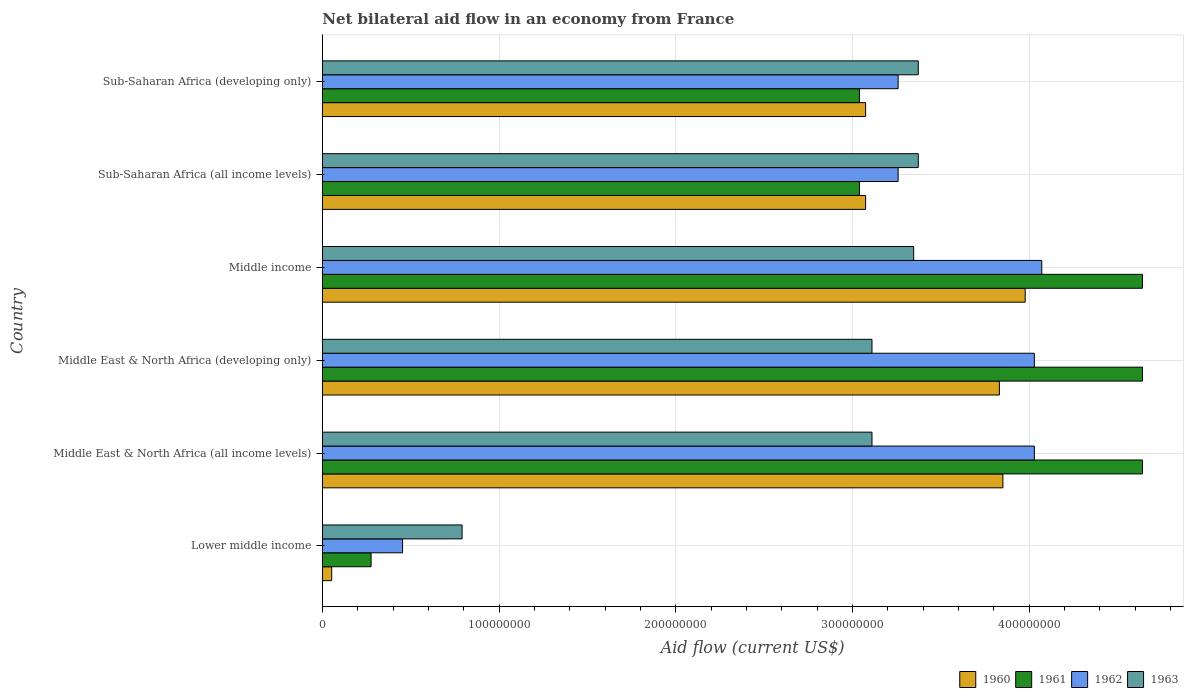How many different coloured bars are there?
Provide a succinct answer. 4. How many groups of bars are there?
Your response must be concise. 6. Are the number of bars on each tick of the Y-axis equal?
Your response must be concise. Yes. What is the label of the 6th group of bars from the top?
Ensure brevity in your answer.  Lower middle income. In how many cases, is the number of bars for a given country not equal to the number of legend labels?
Your answer should be compact. 0. What is the net bilateral aid flow in 1963 in Sub-Saharan Africa (all income levels)?
Offer a terse response. 3.37e+08. Across all countries, what is the maximum net bilateral aid flow in 1960?
Offer a very short reply. 3.98e+08. Across all countries, what is the minimum net bilateral aid flow in 1961?
Provide a short and direct response. 2.76e+07. In which country was the net bilateral aid flow in 1963 minimum?
Offer a very short reply. Lower middle income. What is the total net bilateral aid flow in 1961 in the graph?
Make the answer very short. 2.03e+09. What is the difference between the net bilateral aid flow in 1962 in Middle East & North Africa (developing only) and that in Sub-Saharan Africa (all income levels)?
Provide a succinct answer. 7.71e+07. What is the difference between the net bilateral aid flow in 1963 in Sub-Saharan Africa (all income levels) and the net bilateral aid flow in 1961 in Sub-Saharan Africa (developing only)?
Offer a terse response. 3.33e+07. What is the average net bilateral aid flow in 1963 per country?
Give a very brief answer. 2.85e+08. What is the difference between the net bilateral aid flow in 1963 and net bilateral aid flow in 1960 in Middle East & North Africa (developing only)?
Make the answer very short. -7.21e+07. In how many countries, is the net bilateral aid flow in 1962 greater than 280000000 US$?
Your answer should be very brief. 5. What is the ratio of the net bilateral aid flow in 1960 in Middle East & North Africa (developing only) to that in Sub-Saharan Africa (developing only)?
Keep it short and to the point. 1.25. What is the difference between the highest and the second highest net bilateral aid flow in 1960?
Offer a terse response. 1.26e+07. What is the difference between the highest and the lowest net bilateral aid flow in 1960?
Offer a very short reply. 3.92e+08. In how many countries, is the net bilateral aid flow in 1960 greater than the average net bilateral aid flow in 1960 taken over all countries?
Provide a succinct answer. 5. What does the 4th bar from the bottom in Middle East & North Africa (developing only) represents?
Give a very brief answer. 1963. Are all the bars in the graph horizontal?
Ensure brevity in your answer.  Yes. Are the values on the major ticks of X-axis written in scientific E-notation?
Your answer should be very brief. No. Does the graph contain any zero values?
Provide a succinct answer. No. How many legend labels are there?
Make the answer very short. 4. What is the title of the graph?
Offer a very short reply. Net bilateral aid flow in an economy from France. What is the Aid flow (current US$) in 1960 in Lower middle income?
Ensure brevity in your answer.  5.30e+06. What is the Aid flow (current US$) of 1961 in Lower middle income?
Keep it short and to the point. 2.76e+07. What is the Aid flow (current US$) of 1962 in Lower middle income?
Provide a succinct answer. 4.54e+07. What is the Aid flow (current US$) of 1963 in Lower middle income?
Provide a succinct answer. 7.91e+07. What is the Aid flow (current US$) in 1960 in Middle East & North Africa (all income levels)?
Your answer should be very brief. 3.85e+08. What is the Aid flow (current US$) in 1961 in Middle East & North Africa (all income levels)?
Provide a short and direct response. 4.64e+08. What is the Aid flow (current US$) in 1962 in Middle East & North Africa (all income levels)?
Give a very brief answer. 4.03e+08. What is the Aid flow (current US$) in 1963 in Middle East & North Africa (all income levels)?
Provide a short and direct response. 3.11e+08. What is the Aid flow (current US$) of 1960 in Middle East & North Africa (developing only)?
Give a very brief answer. 3.83e+08. What is the Aid flow (current US$) of 1961 in Middle East & North Africa (developing only)?
Give a very brief answer. 4.64e+08. What is the Aid flow (current US$) in 1962 in Middle East & North Africa (developing only)?
Your response must be concise. 4.03e+08. What is the Aid flow (current US$) of 1963 in Middle East & North Africa (developing only)?
Provide a succinct answer. 3.11e+08. What is the Aid flow (current US$) of 1960 in Middle income?
Keep it short and to the point. 3.98e+08. What is the Aid flow (current US$) of 1961 in Middle income?
Offer a very short reply. 4.64e+08. What is the Aid flow (current US$) of 1962 in Middle income?
Your response must be concise. 4.07e+08. What is the Aid flow (current US$) in 1963 in Middle income?
Your answer should be very brief. 3.35e+08. What is the Aid flow (current US$) of 1960 in Sub-Saharan Africa (all income levels)?
Offer a terse response. 3.08e+08. What is the Aid flow (current US$) in 1961 in Sub-Saharan Africa (all income levels)?
Your answer should be very brief. 3.04e+08. What is the Aid flow (current US$) of 1962 in Sub-Saharan Africa (all income levels)?
Make the answer very short. 3.26e+08. What is the Aid flow (current US$) in 1963 in Sub-Saharan Africa (all income levels)?
Make the answer very short. 3.37e+08. What is the Aid flow (current US$) in 1960 in Sub-Saharan Africa (developing only)?
Make the answer very short. 3.08e+08. What is the Aid flow (current US$) in 1961 in Sub-Saharan Africa (developing only)?
Ensure brevity in your answer.  3.04e+08. What is the Aid flow (current US$) in 1962 in Sub-Saharan Africa (developing only)?
Make the answer very short. 3.26e+08. What is the Aid flow (current US$) of 1963 in Sub-Saharan Africa (developing only)?
Your response must be concise. 3.37e+08. Across all countries, what is the maximum Aid flow (current US$) of 1960?
Keep it short and to the point. 3.98e+08. Across all countries, what is the maximum Aid flow (current US$) of 1961?
Give a very brief answer. 4.64e+08. Across all countries, what is the maximum Aid flow (current US$) of 1962?
Make the answer very short. 4.07e+08. Across all countries, what is the maximum Aid flow (current US$) in 1963?
Your answer should be very brief. 3.37e+08. Across all countries, what is the minimum Aid flow (current US$) of 1960?
Keep it short and to the point. 5.30e+06. Across all countries, what is the minimum Aid flow (current US$) in 1961?
Your answer should be very brief. 2.76e+07. Across all countries, what is the minimum Aid flow (current US$) of 1962?
Provide a succinct answer. 4.54e+07. Across all countries, what is the minimum Aid flow (current US$) of 1963?
Your answer should be very brief. 7.91e+07. What is the total Aid flow (current US$) in 1960 in the graph?
Keep it short and to the point. 1.79e+09. What is the total Aid flow (current US$) in 1961 in the graph?
Keep it short and to the point. 2.03e+09. What is the total Aid flow (current US$) of 1962 in the graph?
Give a very brief answer. 1.91e+09. What is the total Aid flow (current US$) in 1963 in the graph?
Offer a very short reply. 1.71e+09. What is the difference between the Aid flow (current US$) of 1960 in Lower middle income and that in Middle East & North Africa (all income levels)?
Ensure brevity in your answer.  -3.80e+08. What is the difference between the Aid flow (current US$) of 1961 in Lower middle income and that in Middle East & North Africa (all income levels)?
Your answer should be compact. -4.37e+08. What is the difference between the Aid flow (current US$) of 1962 in Lower middle income and that in Middle East & North Africa (all income levels)?
Provide a short and direct response. -3.58e+08. What is the difference between the Aid flow (current US$) of 1963 in Lower middle income and that in Middle East & North Africa (all income levels)?
Provide a succinct answer. -2.32e+08. What is the difference between the Aid flow (current US$) in 1960 in Lower middle income and that in Middle East & North Africa (developing only)?
Your response must be concise. -3.78e+08. What is the difference between the Aid flow (current US$) of 1961 in Lower middle income and that in Middle East & North Africa (developing only)?
Give a very brief answer. -4.37e+08. What is the difference between the Aid flow (current US$) of 1962 in Lower middle income and that in Middle East & North Africa (developing only)?
Ensure brevity in your answer.  -3.58e+08. What is the difference between the Aid flow (current US$) of 1963 in Lower middle income and that in Middle East & North Africa (developing only)?
Give a very brief answer. -2.32e+08. What is the difference between the Aid flow (current US$) in 1960 in Lower middle income and that in Middle income?
Give a very brief answer. -3.92e+08. What is the difference between the Aid flow (current US$) of 1961 in Lower middle income and that in Middle income?
Your answer should be compact. -4.37e+08. What is the difference between the Aid flow (current US$) of 1962 in Lower middle income and that in Middle income?
Ensure brevity in your answer.  -3.62e+08. What is the difference between the Aid flow (current US$) of 1963 in Lower middle income and that in Middle income?
Offer a very short reply. -2.56e+08. What is the difference between the Aid flow (current US$) of 1960 in Lower middle income and that in Sub-Saharan Africa (all income levels)?
Give a very brief answer. -3.02e+08. What is the difference between the Aid flow (current US$) in 1961 in Lower middle income and that in Sub-Saharan Africa (all income levels)?
Ensure brevity in your answer.  -2.76e+08. What is the difference between the Aid flow (current US$) of 1962 in Lower middle income and that in Sub-Saharan Africa (all income levels)?
Your answer should be very brief. -2.80e+08. What is the difference between the Aid flow (current US$) in 1963 in Lower middle income and that in Sub-Saharan Africa (all income levels)?
Ensure brevity in your answer.  -2.58e+08. What is the difference between the Aid flow (current US$) in 1960 in Lower middle income and that in Sub-Saharan Africa (developing only)?
Your answer should be compact. -3.02e+08. What is the difference between the Aid flow (current US$) in 1961 in Lower middle income and that in Sub-Saharan Africa (developing only)?
Provide a short and direct response. -2.76e+08. What is the difference between the Aid flow (current US$) of 1962 in Lower middle income and that in Sub-Saharan Africa (developing only)?
Provide a succinct answer. -2.80e+08. What is the difference between the Aid flow (current US$) in 1963 in Lower middle income and that in Sub-Saharan Africa (developing only)?
Make the answer very short. -2.58e+08. What is the difference between the Aid flow (current US$) of 1960 in Middle East & North Africa (all income levels) and that in Middle East & North Africa (developing only)?
Your response must be concise. 2.00e+06. What is the difference between the Aid flow (current US$) of 1961 in Middle East & North Africa (all income levels) and that in Middle East & North Africa (developing only)?
Your response must be concise. 0. What is the difference between the Aid flow (current US$) in 1960 in Middle East & North Africa (all income levels) and that in Middle income?
Your answer should be very brief. -1.26e+07. What is the difference between the Aid flow (current US$) of 1961 in Middle East & North Africa (all income levels) and that in Middle income?
Your response must be concise. 0. What is the difference between the Aid flow (current US$) in 1962 in Middle East & North Africa (all income levels) and that in Middle income?
Provide a succinct answer. -4.20e+06. What is the difference between the Aid flow (current US$) in 1963 in Middle East & North Africa (all income levels) and that in Middle income?
Offer a very short reply. -2.36e+07. What is the difference between the Aid flow (current US$) in 1960 in Middle East & North Africa (all income levels) and that in Sub-Saharan Africa (all income levels)?
Offer a terse response. 7.77e+07. What is the difference between the Aid flow (current US$) in 1961 in Middle East & North Africa (all income levels) and that in Sub-Saharan Africa (all income levels)?
Make the answer very short. 1.60e+08. What is the difference between the Aid flow (current US$) of 1962 in Middle East & North Africa (all income levels) and that in Sub-Saharan Africa (all income levels)?
Make the answer very short. 7.71e+07. What is the difference between the Aid flow (current US$) of 1963 in Middle East & North Africa (all income levels) and that in Sub-Saharan Africa (all income levels)?
Provide a short and direct response. -2.62e+07. What is the difference between the Aid flow (current US$) of 1960 in Middle East & North Africa (all income levels) and that in Sub-Saharan Africa (developing only)?
Make the answer very short. 7.77e+07. What is the difference between the Aid flow (current US$) of 1961 in Middle East & North Africa (all income levels) and that in Sub-Saharan Africa (developing only)?
Keep it short and to the point. 1.60e+08. What is the difference between the Aid flow (current US$) of 1962 in Middle East & North Africa (all income levels) and that in Sub-Saharan Africa (developing only)?
Keep it short and to the point. 7.71e+07. What is the difference between the Aid flow (current US$) of 1963 in Middle East & North Africa (all income levels) and that in Sub-Saharan Africa (developing only)?
Give a very brief answer. -2.62e+07. What is the difference between the Aid flow (current US$) in 1960 in Middle East & North Africa (developing only) and that in Middle income?
Offer a terse response. -1.46e+07. What is the difference between the Aid flow (current US$) of 1962 in Middle East & North Africa (developing only) and that in Middle income?
Your answer should be very brief. -4.20e+06. What is the difference between the Aid flow (current US$) of 1963 in Middle East & North Africa (developing only) and that in Middle income?
Offer a terse response. -2.36e+07. What is the difference between the Aid flow (current US$) in 1960 in Middle East & North Africa (developing only) and that in Sub-Saharan Africa (all income levels)?
Keep it short and to the point. 7.57e+07. What is the difference between the Aid flow (current US$) in 1961 in Middle East & North Africa (developing only) and that in Sub-Saharan Africa (all income levels)?
Ensure brevity in your answer.  1.60e+08. What is the difference between the Aid flow (current US$) of 1962 in Middle East & North Africa (developing only) and that in Sub-Saharan Africa (all income levels)?
Your answer should be very brief. 7.71e+07. What is the difference between the Aid flow (current US$) of 1963 in Middle East & North Africa (developing only) and that in Sub-Saharan Africa (all income levels)?
Offer a terse response. -2.62e+07. What is the difference between the Aid flow (current US$) in 1960 in Middle East & North Africa (developing only) and that in Sub-Saharan Africa (developing only)?
Keep it short and to the point. 7.57e+07. What is the difference between the Aid flow (current US$) of 1961 in Middle East & North Africa (developing only) and that in Sub-Saharan Africa (developing only)?
Your response must be concise. 1.60e+08. What is the difference between the Aid flow (current US$) of 1962 in Middle East & North Africa (developing only) and that in Sub-Saharan Africa (developing only)?
Make the answer very short. 7.71e+07. What is the difference between the Aid flow (current US$) of 1963 in Middle East & North Africa (developing only) and that in Sub-Saharan Africa (developing only)?
Ensure brevity in your answer.  -2.62e+07. What is the difference between the Aid flow (current US$) of 1960 in Middle income and that in Sub-Saharan Africa (all income levels)?
Give a very brief answer. 9.03e+07. What is the difference between the Aid flow (current US$) in 1961 in Middle income and that in Sub-Saharan Africa (all income levels)?
Offer a very short reply. 1.60e+08. What is the difference between the Aid flow (current US$) in 1962 in Middle income and that in Sub-Saharan Africa (all income levels)?
Your answer should be compact. 8.13e+07. What is the difference between the Aid flow (current US$) in 1963 in Middle income and that in Sub-Saharan Africa (all income levels)?
Provide a short and direct response. -2.60e+06. What is the difference between the Aid flow (current US$) in 1960 in Middle income and that in Sub-Saharan Africa (developing only)?
Keep it short and to the point. 9.03e+07. What is the difference between the Aid flow (current US$) in 1961 in Middle income and that in Sub-Saharan Africa (developing only)?
Your answer should be very brief. 1.60e+08. What is the difference between the Aid flow (current US$) in 1962 in Middle income and that in Sub-Saharan Africa (developing only)?
Your response must be concise. 8.13e+07. What is the difference between the Aid flow (current US$) in 1963 in Middle income and that in Sub-Saharan Africa (developing only)?
Your answer should be compact. -2.60e+06. What is the difference between the Aid flow (current US$) in 1962 in Sub-Saharan Africa (all income levels) and that in Sub-Saharan Africa (developing only)?
Ensure brevity in your answer.  0. What is the difference between the Aid flow (current US$) in 1960 in Lower middle income and the Aid flow (current US$) in 1961 in Middle East & North Africa (all income levels)?
Provide a succinct answer. -4.59e+08. What is the difference between the Aid flow (current US$) in 1960 in Lower middle income and the Aid flow (current US$) in 1962 in Middle East & North Africa (all income levels)?
Your answer should be very brief. -3.98e+08. What is the difference between the Aid flow (current US$) of 1960 in Lower middle income and the Aid flow (current US$) of 1963 in Middle East & North Africa (all income levels)?
Provide a succinct answer. -3.06e+08. What is the difference between the Aid flow (current US$) of 1961 in Lower middle income and the Aid flow (current US$) of 1962 in Middle East & North Africa (all income levels)?
Make the answer very short. -3.75e+08. What is the difference between the Aid flow (current US$) in 1961 in Lower middle income and the Aid flow (current US$) in 1963 in Middle East & North Africa (all income levels)?
Your answer should be very brief. -2.84e+08. What is the difference between the Aid flow (current US$) in 1962 in Lower middle income and the Aid flow (current US$) in 1963 in Middle East & North Africa (all income levels)?
Offer a terse response. -2.66e+08. What is the difference between the Aid flow (current US$) in 1960 in Lower middle income and the Aid flow (current US$) in 1961 in Middle East & North Africa (developing only)?
Provide a short and direct response. -4.59e+08. What is the difference between the Aid flow (current US$) of 1960 in Lower middle income and the Aid flow (current US$) of 1962 in Middle East & North Africa (developing only)?
Your answer should be compact. -3.98e+08. What is the difference between the Aid flow (current US$) in 1960 in Lower middle income and the Aid flow (current US$) in 1963 in Middle East & North Africa (developing only)?
Give a very brief answer. -3.06e+08. What is the difference between the Aid flow (current US$) of 1961 in Lower middle income and the Aid flow (current US$) of 1962 in Middle East & North Africa (developing only)?
Offer a terse response. -3.75e+08. What is the difference between the Aid flow (current US$) of 1961 in Lower middle income and the Aid flow (current US$) of 1963 in Middle East & North Africa (developing only)?
Provide a short and direct response. -2.84e+08. What is the difference between the Aid flow (current US$) of 1962 in Lower middle income and the Aid flow (current US$) of 1963 in Middle East & North Africa (developing only)?
Offer a terse response. -2.66e+08. What is the difference between the Aid flow (current US$) in 1960 in Lower middle income and the Aid flow (current US$) in 1961 in Middle income?
Give a very brief answer. -4.59e+08. What is the difference between the Aid flow (current US$) of 1960 in Lower middle income and the Aid flow (current US$) of 1962 in Middle income?
Ensure brevity in your answer.  -4.02e+08. What is the difference between the Aid flow (current US$) in 1960 in Lower middle income and the Aid flow (current US$) in 1963 in Middle income?
Provide a short and direct response. -3.29e+08. What is the difference between the Aid flow (current US$) in 1961 in Lower middle income and the Aid flow (current US$) in 1962 in Middle income?
Offer a terse response. -3.80e+08. What is the difference between the Aid flow (current US$) of 1961 in Lower middle income and the Aid flow (current US$) of 1963 in Middle income?
Your answer should be very brief. -3.07e+08. What is the difference between the Aid flow (current US$) of 1962 in Lower middle income and the Aid flow (current US$) of 1963 in Middle income?
Make the answer very short. -2.89e+08. What is the difference between the Aid flow (current US$) in 1960 in Lower middle income and the Aid flow (current US$) in 1961 in Sub-Saharan Africa (all income levels)?
Provide a short and direct response. -2.99e+08. What is the difference between the Aid flow (current US$) in 1960 in Lower middle income and the Aid flow (current US$) in 1962 in Sub-Saharan Africa (all income levels)?
Your answer should be very brief. -3.21e+08. What is the difference between the Aid flow (current US$) in 1960 in Lower middle income and the Aid flow (current US$) in 1963 in Sub-Saharan Africa (all income levels)?
Provide a short and direct response. -3.32e+08. What is the difference between the Aid flow (current US$) in 1961 in Lower middle income and the Aid flow (current US$) in 1962 in Sub-Saharan Africa (all income levels)?
Keep it short and to the point. -2.98e+08. What is the difference between the Aid flow (current US$) of 1961 in Lower middle income and the Aid flow (current US$) of 1963 in Sub-Saharan Africa (all income levels)?
Your response must be concise. -3.10e+08. What is the difference between the Aid flow (current US$) in 1962 in Lower middle income and the Aid flow (current US$) in 1963 in Sub-Saharan Africa (all income levels)?
Keep it short and to the point. -2.92e+08. What is the difference between the Aid flow (current US$) in 1960 in Lower middle income and the Aid flow (current US$) in 1961 in Sub-Saharan Africa (developing only)?
Give a very brief answer. -2.99e+08. What is the difference between the Aid flow (current US$) in 1960 in Lower middle income and the Aid flow (current US$) in 1962 in Sub-Saharan Africa (developing only)?
Give a very brief answer. -3.21e+08. What is the difference between the Aid flow (current US$) of 1960 in Lower middle income and the Aid flow (current US$) of 1963 in Sub-Saharan Africa (developing only)?
Make the answer very short. -3.32e+08. What is the difference between the Aid flow (current US$) in 1961 in Lower middle income and the Aid flow (current US$) in 1962 in Sub-Saharan Africa (developing only)?
Provide a succinct answer. -2.98e+08. What is the difference between the Aid flow (current US$) of 1961 in Lower middle income and the Aid flow (current US$) of 1963 in Sub-Saharan Africa (developing only)?
Your answer should be compact. -3.10e+08. What is the difference between the Aid flow (current US$) in 1962 in Lower middle income and the Aid flow (current US$) in 1963 in Sub-Saharan Africa (developing only)?
Your answer should be very brief. -2.92e+08. What is the difference between the Aid flow (current US$) in 1960 in Middle East & North Africa (all income levels) and the Aid flow (current US$) in 1961 in Middle East & North Africa (developing only)?
Keep it short and to the point. -7.90e+07. What is the difference between the Aid flow (current US$) in 1960 in Middle East & North Africa (all income levels) and the Aid flow (current US$) in 1962 in Middle East & North Africa (developing only)?
Keep it short and to the point. -1.78e+07. What is the difference between the Aid flow (current US$) of 1960 in Middle East & North Africa (all income levels) and the Aid flow (current US$) of 1963 in Middle East & North Africa (developing only)?
Offer a very short reply. 7.41e+07. What is the difference between the Aid flow (current US$) of 1961 in Middle East & North Africa (all income levels) and the Aid flow (current US$) of 1962 in Middle East & North Africa (developing only)?
Offer a terse response. 6.12e+07. What is the difference between the Aid flow (current US$) in 1961 in Middle East & North Africa (all income levels) and the Aid flow (current US$) in 1963 in Middle East & North Africa (developing only)?
Offer a terse response. 1.53e+08. What is the difference between the Aid flow (current US$) of 1962 in Middle East & North Africa (all income levels) and the Aid flow (current US$) of 1963 in Middle East & North Africa (developing only)?
Give a very brief answer. 9.19e+07. What is the difference between the Aid flow (current US$) in 1960 in Middle East & North Africa (all income levels) and the Aid flow (current US$) in 1961 in Middle income?
Make the answer very short. -7.90e+07. What is the difference between the Aid flow (current US$) of 1960 in Middle East & North Africa (all income levels) and the Aid flow (current US$) of 1962 in Middle income?
Offer a terse response. -2.20e+07. What is the difference between the Aid flow (current US$) of 1960 in Middle East & North Africa (all income levels) and the Aid flow (current US$) of 1963 in Middle income?
Give a very brief answer. 5.05e+07. What is the difference between the Aid flow (current US$) in 1961 in Middle East & North Africa (all income levels) and the Aid flow (current US$) in 1962 in Middle income?
Provide a succinct answer. 5.70e+07. What is the difference between the Aid flow (current US$) of 1961 in Middle East & North Africa (all income levels) and the Aid flow (current US$) of 1963 in Middle income?
Your answer should be very brief. 1.30e+08. What is the difference between the Aid flow (current US$) in 1962 in Middle East & North Africa (all income levels) and the Aid flow (current US$) in 1963 in Middle income?
Ensure brevity in your answer.  6.83e+07. What is the difference between the Aid flow (current US$) in 1960 in Middle East & North Africa (all income levels) and the Aid flow (current US$) in 1961 in Sub-Saharan Africa (all income levels)?
Give a very brief answer. 8.12e+07. What is the difference between the Aid flow (current US$) of 1960 in Middle East & North Africa (all income levels) and the Aid flow (current US$) of 1962 in Sub-Saharan Africa (all income levels)?
Make the answer very short. 5.93e+07. What is the difference between the Aid flow (current US$) of 1960 in Middle East & North Africa (all income levels) and the Aid flow (current US$) of 1963 in Sub-Saharan Africa (all income levels)?
Offer a very short reply. 4.79e+07. What is the difference between the Aid flow (current US$) of 1961 in Middle East & North Africa (all income levels) and the Aid flow (current US$) of 1962 in Sub-Saharan Africa (all income levels)?
Your answer should be compact. 1.38e+08. What is the difference between the Aid flow (current US$) of 1961 in Middle East & North Africa (all income levels) and the Aid flow (current US$) of 1963 in Sub-Saharan Africa (all income levels)?
Your answer should be compact. 1.27e+08. What is the difference between the Aid flow (current US$) in 1962 in Middle East & North Africa (all income levels) and the Aid flow (current US$) in 1963 in Sub-Saharan Africa (all income levels)?
Your answer should be very brief. 6.57e+07. What is the difference between the Aid flow (current US$) in 1960 in Middle East & North Africa (all income levels) and the Aid flow (current US$) in 1961 in Sub-Saharan Africa (developing only)?
Ensure brevity in your answer.  8.12e+07. What is the difference between the Aid flow (current US$) of 1960 in Middle East & North Africa (all income levels) and the Aid flow (current US$) of 1962 in Sub-Saharan Africa (developing only)?
Offer a terse response. 5.93e+07. What is the difference between the Aid flow (current US$) of 1960 in Middle East & North Africa (all income levels) and the Aid flow (current US$) of 1963 in Sub-Saharan Africa (developing only)?
Offer a terse response. 4.79e+07. What is the difference between the Aid flow (current US$) in 1961 in Middle East & North Africa (all income levels) and the Aid flow (current US$) in 1962 in Sub-Saharan Africa (developing only)?
Ensure brevity in your answer.  1.38e+08. What is the difference between the Aid flow (current US$) in 1961 in Middle East & North Africa (all income levels) and the Aid flow (current US$) in 1963 in Sub-Saharan Africa (developing only)?
Provide a succinct answer. 1.27e+08. What is the difference between the Aid flow (current US$) of 1962 in Middle East & North Africa (all income levels) and the Aid flow (current US$) of 1963 in Sub-Saharan Africa (developing only)?
Your answer should be very brief. 6.57e+07. What is the difference between the Aid flow (current US$) in 1960 in Middle East & North Africa (developing only) and the Aid flow (current US$) in 1961 in Middle income?
Give a very brief answer. -8.10e+07. What is the difference between the Aid flow (current US$) of 1960 in Middle East & North Africa (developing only) and the Aid flow (current US$) of 1962 in Middle income?
Give a very brief answer. -2.40e+07. What is the difference between the Aid flow (current US$) in 1960 in Middle East & North Africa (developing only) and the Aid flow (current US$) in 1963 in Middle income?
Your answer should be compact. 4.85e+07. What is the difference between the Aid flow (current US$) of 1961 in Middle East & North Africa (developing only) and the Aid flow (current US$) of 1962 in Middle income?
Your response must be concise. 5.70e+07. What is the difference between the Aid flow (current US$) of 1961 in Middle East & North Africa (developing only) and the Aid flow (current US$) of 1963 in Middle income?
Give a very brief answer. 1.30e+08. What is the difference between the Aid flow (current US$) in 1962 in Middle East & North Africa (developing only) and the Aid flow (current US$) in 1963 in Middle income?
Offer a terse response. 6.83e+07. What is the difference between the Aid flow (current US$) in 1960 in Middle East & North Africa (developing only) and the Aid flow (current US$) in 1961 in Sub-Saharan Africa (all income levels)?
Give a very brief answer. 7.92e+07. What is the difference between the Aid flow (current US$) of 1960 in Middle East & North Africa (developing only) and the Aid flow (current US$) of 1962 in Sub-Saharan Africa (all income levels)?
Provide a succinct answer. 5.73e+07. What is the difference between the Aid flow (current US$) in 1960 in Middle East & North Africa (developing only) and the Aid flow (current US$) in 1963 in Sub-Saharan Africa (all income levels)?
Provide a succinct answer. 4.59e+07. What is the difference between the Aid flow (current US$) of 1961 in Middle East & North Africa (developing only) and the Aid flow (current US$) of 1962 in Sub-Saharan Africa (all income levels)?
Keep it short and to the point. 1.38e+08. What is the difference between the Aid flow (current US$) of 1961 in Middle East & North Africa (developing only) and the Aid flow (current US$) of 1963 in Sub-Saharan Africa (all income levels)?
Provide a succinct answer. 1.27e+08. What is the difference between the Aid flow (current US$) in 1962 in Middle East & North Africa (developing only) and the Aid flow (current US$) in 1963 in Sub-Saharan Africa (all income levels)?
Provide a short and direct response. 6.57e+07. What is the difference between the Aid flow (current US$) in 1960 in Middle East & North Africa (developing only) and the Aid flow (current US$) in 1961 in Sub-Saharan Africa (developing only)?
Your answer should be very brief. 7.92e+07. What is the difference between the Aid flow (current US$) of 1960 in Middle East & North Africa (developing only) and the Aid flow (current US$) of 1962 in Sub-Saharan Africa (developing only)?
Keep it short and to the point. 5.73e+07. What is the difference between the Aid flow (current US$) of 1960 in Middle East & North Africa (developing only) and the Aid flow (current US$) of 1963 in Sub-Saharan Africa (developing only)?
Offer a very short reply. 4.59e+07. What is the difference between the Aid flow (current US$) of 1961 in Middle East & North Africa (developing only) and the Aid flow (current US$) of 1962 in Sub-Saharan Africa (developing only)?
Offer a terse response. 1.38e+08. What is the difference between the Aid flow (current US$) of 1961 in Middle East & North Africa (developing only) and the Aid flow (current US$) of 1963 in Sub-Saharan Africa (developing only)?
Ensure brevity in your answer.  1.27e+08. What is the difference between the Aid flow (current US$) of 1962 in Middle East & North Africa (developing only) and the Aid flow (current US$) of 1963 in Sub-Saharan Africa (developing only)?
Provide a short and direct response. 6.57e+07. What is the difference between the Aid flow (current US$) in 1960 in Middle income and the Aid flow (current US$) in 1961 in Sub-Saharan Africa (all income levels)?
Ensure brevity in your answer.  9.38e+07. What is the difference between the Aid flow (current US$) in 1960 in Middle income and the Aid flow (current US$) in 1962 in Sub-Saharan Africa (all income levels)?
Offer a very short reply. 7.19e+07. What is the difference between the Aid flow (current US$) in 1960 in Middle income and the Aid flow (current US$) in 1963 in Sub-Saharan Africa (all income levels)?
Provide a succinct answer. 6.05e+07. What is the difference between the Aid flow (current US$) of 1961 in Middle income and the Aid flow (current US$) of 1962 in Sub-Saharan Africa (all income levels)?
Your answer should be very brief. 1.38e+08. What is the difference between the Aid flow (current US$) in 1961 in Middle income and the Aid flow (current US$) in 1963 in Sub-Saharan Africa (all income levels)?
Keep it short and to the point. 1.27e+08. What is the difference between the Aid flow (current US$) in 1962 in Middle income and the Aid flow (current US$) in 1963 in Sub-Saharan Africa (all income levels)?
Make the answer very short. 6.99e+07. What is the difference between the Aid flow (current US$) of 1960 in Middle income and the Aid flow (current US$) of 1961 in Sub-Saharan Africa (developing only)?
Provide a succinct answer. 9.38e+07. What is the difference between the Aid flow (current US$) of 1960 in Middle income and the Aid flow (current US$) of 1962 in Sub-Saharan Africa (developing only)?
Keep it short and to the point. 7.19e+07. What is the difference between the Aid flow (current US$) in 1960 in Middle income and the Aid flow (current US$) in 1963 in Sub-Saharan Africa (developing only)?
Make the answer very short. 6.05e+07. What is the difference between the Aid flow (current US$) of 1961 in Middle income and the Aid flow (current US$) of 1962 in Sub-Saharan Africa (developing only)?
Your answer should be compact. 1.38e+08. What is the difference between the Aid flow (current US$) in 1961 in Middle income and the Aid flow (current US$) in 1963 in Sub-Saharan Africa (developing only)?
Offer a very short reply. 1.27e+08. What is the difference between the Aid flow (current US$) in 1962 in Middle income and the Aid flow (current US$) in 1963 in Sub-Saharan Africa (developing only)?
Make the answer very short. 6.99e+07. What is the difference between the Aid flow (current US$) of 1960 in Sub-Saharan Africa (all income levels) and the Aid flow (current US$) of 1961 in Sub-Saharan Africa (developing only)?
Offer a terse response. 3.50e+06. What is the difference between the Aid flow (current US$) in 1960 in Sub-Saharan Africa (all income levels) and the Aid flow (current US$) in 1962 in Sub-Saharan Africa (developing only)?
Provide a succinct answer. -1.84e+07. What is the difference between the Aid flow (current US$) of 1960 in Sub-Saharan Africa (all income levels) and the Aid flow (current US$) of 1963 in Sub-Saharan Africa (developing only)?
Offer a very short reply. -2.98e+07. What is the difference between the Aid flow (current US$) in 1961 in Sub-Saharan Africa (all income levels) and the Aid flow (current US$) in 1962 in Sub-Saharan Africa (developing only)?
Offer a terse response. -2.19e+07. What is the difference between the Aid flow (current US$) in 1961 in Sub-Saharan Africa (all income levels) and the Aid flow (current US$) in 1963 in Sub-Saharan Africa (developing only)?
Provide a short and direct response. -3.33e+07. What is the difference between the Aid flow (current US$) in 1962 in Sub-Saharan Africa (all income levels) and the Aid flow (current US$) in 1963 in Sub-Saharan Africa (developing only)?
Your response must be concise. -1.14e+07. What is the average Aid flow (current US$) in 1960 per country?
Make the answer very short. 2.98e+08. What is the average Aid flow (current US$) in 1961 per country?
Your answer should be compact. 3.38e+08. What is the average Aid flow (current US$) of 1962 per country?
Provide a succinct answer. 3.18e+08. What is the average Aid flow (current US$) of 1963 per country?
Your response must be concise. 2.85e+08. What is the difference between the Aid flow (current US$) of 1960 and Aid flow (current US$) of 1961 in Lower middle income?
Your response must be concise. -2.23e+07. What is the difference between the Aid flow (current US$) in 1960 and Aid flow (current US$) in 1962 in Lower middle income?
Offer a terse response. -4.01e+07. What is the difference between the Aid flow (current US$) in 1960 and Aid flow (current US$) in 1963 in Lower middle income?
Your answer should be compact. -7.38e+07. What is the difference between the Aid flow (current US$) in 1961 and Aid flow (current US$) in 1962 in Lower middle income?
Offer a very short reply. -1.78e+07. What is the difference between the Aid flow (current US$) in 1961 and Aid flow (current US$) in 1963 in Lower middle income?
Provide a short and direct response. -5.15e+07. What is the difference between the Aid flow (current US$) in 1962 and Aid flow (current US$) in 1963 in Lower middle income?
Keep it short and to the point. -3.37e+07. What is the difference between the Aid flow (current US$) of 1960 and Aid flow (current US$) of 1961 in Middle East & North Africa (all income levels)?
Give a very brief answer. -7.90e+07. What is the difference between the Aid flow (current US$) of 1960 and Aid flow (current US$) of 1962 in Middle East & North Africa (all income levels)?
Give a very brief answer. -1.78e+07. What is the difference between the Aid flow (current US$) of 1960 and Aid flow (current US$) of 1963 in Middle East & North Africa (all income levels)?
Keep it short and to the point. 7.41e+07. What is the difference between the Aid flow (current US$) in 1961 and Aid flow (current US$) in 1962 in Middle East & North Africa (all income levels)?
Provide a succinct answer. 6.12e+07. What is the difference between the Aid flow (current US$) in 1961 and Aid flow (current US$) in 1963 in Middle East & North Africa (all income levels)?
Give a very brief answer. 1.53e+08. What is the difference between the Aid flow (current US$) in 1962 and Aid flow (current US$) in 1963 in Middle East & North Africa (all income levels)?
Keep it short and to the point. 9.19e+07. What is the difference between the Aid flow (current US$) in 1960 and Aid flow (current US$) in 1961 in Middle East & North Africa (developing only)?
Ensure brevity in your answer.  -8.10e+07. What is the difference between the Aid flow (current US$) of 1960 and Aid flow (current US$) of 1962 in Middle East & North Africa (developing only)?
Provide a succinct answer. -1.98e+07. What is the difference between the Aid flow (current US$) in 1960 and Aid flow (current US$) in 1963 in Middle East & North Africa (developing only)?
Provide a short and direct response. 7.21e+07. What is the difference between the Aid flow (current US$) in 1961 and Aid flow (current US$) in 1962 in Middle East & North Africa (developing only)?
Ensure brevity in your answer.  6.12e+07. What is the difference between the Aid flow (current US$) in 1961 and Aid flow (current US$) in 1963 in Middle East & North Africa (developing only)?
Make the answer very short. 1.53e+08. What is the difference between the Aid flow (current US$) of 1962 and Aid flow (current US$) of 1963 in Middle East & North Africa (developing only)?
Your response must be concise. 9.19e+07. What is the difference between the Aid flow (current US$) in 1960 and Aid flow (current US$) in 1961 in Middle income?
Give a very brief answer. -6.64e+07. What is the difference between the Aid flow (current US$) of 1960 and Aid flow (current US$) of 1962 in Middle income?
Your answer should be compact. -9.40e+06. What is the difference between the Aid flow (current US$) of 1960 and Aid flow (current US$) of 1963 in Middle income?
Your answer should be very brief. 6.31e+07. What is the difference between the Aid flow (current US$) of 1961 and Aid flow (current US$) of 1962 in Middle income?
Offer a very short reply. 5.70e+07. What is the difference between the Aid flow (current US$) of 1961 and Aid flow (current US$) of 1963 in Middle income?
Ensure brevity in your answer.  1.30e+08. What is the difference between the Aid flow (current US$) in 1962 and Aid flow (current US$) in 1963 in Middle income?
Your response must be concise. 7.25e+07. What is the difference between the Aid flow (current US$) of 1960 and Aid flow (current US$) of 1961 in Sub-Saharan Africa (all income levels)?
Give a very brief answer. 3.50e+06. What is the difference between the Aid flow (current US$) of 1960 and Aid flow (current US$) of 1962 in Sub-Saharan Africa (all income levels)?
Provide a short and direct response. -1.84e+07. What is the difference between the Aid flow (current US$) of 1960 and Aid flow (current US$) of 1963 in Sub-Saharan Africa (all income levels)?
Your answer should be very brief. -2.98e+07. What is the difference between the Aid flow (current US$) of 1961 and Aid flow (current US$) of 1962 in Sub-Saharan Africa (all income levels)?
Give a very brief answer. -2.19e+07. What is the difference between the Aid flow (current US$) in 1961 and Aid flow (current US$) in 1963 in Sub-Saharan Africa (all income levels)?
Your response must be concise. -3.33e+07. What is the difference between the Aid flow (current US$) in 1962 and Aid flow (current US$) in 1963 in Sub-Saharan Africa (all income levels)?
Your answer should be compact. -1.14e+07. What is the difference between the Aid flow (current US$) of 1960 and Aid flow (current US$) of 1961 in Sub-Saharan Africa (developing only)?
Give a very brief answer. 3.50e+06. What is the difference between the Aid flow (current US$) of 1960 and Aid flow (current US$) of 1962 in Sub-Saharan Africa (developing only)?
Keep it short and to the point. -1.84e+07. What is the difference between the Aid flow (current US$) in 1960 and Aid flow (current US$) in 1963 in Sub-Saharan Africa (developing only)?
Your answer should be very brief. -2.98e+07. What is the difference between the Aid flow (current US$) in 1961 and Aid flow (current US$) in 1962 in Sub-Saharan Africa (developing only)?
Provide a succinct answer. -2.19e+07. What is the difference between the Aid flow (current US$) in 1961 and Aid flow (current US$) in 1963 in Sub-Saharan Africa (developing only)?
Offer a terse response. -3.33e+07. What is the difference between the Aid flow (current US$) in 1962 and Aid flow (current US$) in 1963 in Sub-Saharan Africa (developing only)?
Keep it short and to the point. -1.14e+07. What is the ratio of the Aid flow (current US$) of 1960 in Lower middle income to that in Middle East & North Africa (all income levels)?
Make the answer very short. 0.01. What is the ratio of the Aid flow (current US$) in 1961 in Lower middle income to that in Middle East & North Africa (all income levels)?
Ensure brevity in your answer.  0.06. What is the ratio of the Aid flow (current US$) of 1962 in Lower middle income to that in Middle East & North Africa (all income levels)?
Your answer should be very brief. 0.11. What is the ratio of the Aid flow (current US$) in 1963 in Lower middle income to that in Middle East & North Africa (all income levels)?
Provide a short and direct response. 0.25. What is the ratio of the Aid flow (current US$) of 1960 in Lower middle income to that in Middle East & North Africa (developing only)?
Your response must be concise. 0.01. What is the ratio of the Aid flow (current US$) in 1961 in Lower middle income to that in Middle East & North Africa (developing only)?
Keep it short and to the point. 0.06. What is the ratio of the Aid flow (current US$) of 1962 in Lower middle income to that in Middle East & North Africa (developing only)?
Your answer should be very brief. 0.11. What is the ratio of the Aid flow (current US$) of 1963 in Lower middle income to that in Middle East & North Africa (developing only)?
Provide a short and direct response. 0.25. What is the ratio of the Aid flow (current US$) of 1960 in Lower middle income to that in Middle income?
Ensure brevity in your answer.  0.01. What is the ratio of the Aid flow (current US$) in 1961 in Lower middle income to that in Middle income?
Offer a very short reply. 0.06. What is the ratio of the Aid flow (current US$) of 1962 in Lower middle income to that in Middle income?
Offer a terse response. 0.11. What is the ratio of the Aid flow (current US$) of 1963 in Lower middle income to that in Middle income?
Ensure brevity in your answer.  0.24. What is the ratio of the Aid flow (current US$) in 1960 in Lower middle income to that in Sub-Saharan Africa (all income levels)?
Your answer should be compact. 0.02. What is the ratio of the Aid flow (current US$) in 1961 in Lower middle income to that in Sub-Saharan Africa (all income levels)?
Provide a succinct answer. 0.09. What is the ratio of the Aid flow (current US$) in 1962 in Lower middle income to that in Sub-Saharan Africa (all income levels)?
Provide a succinct answer. 0.14. What is the ratio of the Aid flow (current US$) in 1963 in Lower middle income to that in Sub-Saharan Africa (all income levels)?
Offer a very short reply. 0.23. What is the ratio of the Aid flow (current US$) in 1960 in Lower middle income to that in Sub-Saharan Africa (developing only)?
Your answer should be very brief. 0.02. What is the ratio of the Aid flow (current US$) in 1961 in Lower middle income to that in Sub-Saharan Africa (developing only)?
Give a very brief answer. 0.09. What is the ratio of the Aid flow (current US$) in 1962 in Lower middle income to that in Sub-Saharan Africa (developing only)?
Give a very brief answer. 0.14. What is the ratio of the Aid flow (current US$) in 1963 in Lower middle income to that in Sub-Saharan Africa (developing only)?
Provide a short and direct response. 0.23. What is the ratio of the Aid flow (current US$) in 1961 in Middle East & North Africa (all income levels) to that in Middle East & North Africa (developing only)?
Give a very brief answer. 1. What is the ratio of the Aid flow (current US$) of 1963 in Middle East & North Africa (all income levels) to that in Middle East & North Africa (developing only)?
Offer a terse response. 1. What is the ratio of the Aid flow (current US$) in 1960 in Middle East & North Africa (all income levels) to that in Middle income?
Provide a succinct answer. 0.97. What is the ratio of the Aid flow (current US$) of 1961 in Middle East & North Africa (all income levels) to that in Middle income?
Your response must be concise. 1. What is the ratio of the Aid flow (current US$) of 1963 in Middle East & North Africa (all income levels) to that in Middle income?
Provide a succinct answer. 0.93. What is the ratio of the Aid flow (current US$) of 1960 in Middle East & North Africa (all income levels) to that in Sub-Saharan Africa (all income levels)?
Offer a very short reply. 1.25. What is the ratio of the Aid flow (current US$) of 1961 in Middle East & North Africa (all income levels) to that in Sub-Saharan Africa (all income levels)?
Offer a terse response. 1.53. What is the ratio of the Aid flow (current US$) of 1962 in Middle East & North Africa (all income levels) to that in Sub-Saharan Africa (all income levels)?
Offer a very short reply. 1.24. What is the ratio of the Aid flow (current US$) of 1963 in Middle East & North Africa (all income levels) to that in Sub-Saharan Africa (all income levels)?
Your response must be concise. 0.92. What is the ratio of the Aid flow (current US$) of 1960 in Middle East & North Africa (all income levels) to that in Sub-Saharan Africa (developing only)?
Offer a terse response. 1.25. What is the ratio of the Aid flow (current US$) of 1961 in Middle East & North Africa (all income levels) to that in Sub-Saharan Africa (developing only)?
Provide a succinct answer. 1.53. What is the ratio of the Aid flow (current US$) in 1962 in Middle East & North Africa (all income levels) to that in Sub-Saharan Africa (developing only)?
Keep it short and to the point. 1.24. What is the ratio of the Aid flow (current US$) in 1963 in Middle East & North Africa (all income levels) to that in Sub-Saharan Africa (developing only)?
Offer a very short reply. 0.92. What is the ratio of the Aid flow (current US$) of 1960 in Middle East & North Africa (developing only) to that in Middle income?
Give a very brief answer. 0.96. What is the ratio of the Aid flow (current US$) in 1961 in Middle East & North Africa (developing only) to that in Middle income?
Make the answer very short. 1. What is the ratio of the Aid flow (current US$) of 1963 in Middle East & North Africa (developing only) to that in Middle income?
Keep it short and to the point. 0.93. What is the ratio of the Aid flow (current US$) in 1960 in Middle East & North Africa (developing only) to that in Sub-Saharan Africa (all income levels)?
Give a very brief answer. 1.25. What is the ratio of the Aid flow (current US$) in 1961 in Middle East & North Africa (developing only) to that in Sub-Saharan Africa (all income levels)?
Offer a very short reply. 1.53. What is the ratio of the Aid flow (current US$) in 1962 in Middle East & North Africa (developing only) to that in Sub-Saharan Africa (all income levels)?
Your answer should be compact. 1.24. What is the ratio of the Aid flow (current US$) of 1963 in Middle East & North Africa (developing only) to that in Sub-Saharan Africa (all income levels)?
Ensure brevity in your answer.  0.92. What is the ratio of the Aid flow (current US$) in 1960 in Middle East & North Africa (developing only) to that in Sub-Saharan Africa (developing only)?
Keep it short and to the point. 1.25. What is the ratio of the Aid flow (current US$) in 1961 in Middle East & North Africa (developing only) to that in Sub-Saharan Africa (developing only)?
Provide a short and direct response. 1.53. What is the ratio of the Aid flow (current US$) in 1962 in Middle East & North Africa (developing only) to that in Sub-Saharan Africa (developing only)?
Make the answer very short. 1.24. What is the ratio of the Aid flow (current US$) in 1963 in Middle East & North Africa (developing only) to that in Sub-Saharan Africa (developing only)?
Offer a very short reply. 0.92. What is the ratio of the Aid flow (current US$) in 1960 in Middle income to that in Sub-Saharan Africa (all income levels)?
Provide a succinct answer. 1.29. What is the ratio of the Aid flow (current US$) in 1961 in Middle income to that in Sub-Saharan Africa (all income levels)?
Keep it short and to the point. 1.53. What is the ratio of the Aid flow (current US$) in 1962 in Middle income to that in Sub-Saharan Africa (all income levels)?
Ensure brevity in your answer.  1.25. What is the ratio of the Aid flow (current US$) in 1963 in Middle income to that in Sub-Saharan Africa (all income levels)?
Offer a terse response. 0.99. What is the ratio of the Aid flow (current US$) in 1960 in Middle income to that in Sub-Saharan Africa (developing only)?
Your answer should be compact. 1.29. What is the ratio of the Aid flow (current US$) in 1961 in Middle income to that in Sub-Saharan Africa (developing only)?
Your answer should be very brief. 1.53. What is the ratio of the Aid flow (current US$) of 1962 in Middle income to that in Sub-Saharan Africa (developing only)?
Make the answer very short. 1.25. What is the ratio of the Aid flow (current US$) in 1963 in Middle income to that in Sub-Saharan Africa (developing only)?
Offer a very short reply. 0.99. What is the ratio of the Aid flow (current US$) of 1960 in Sub-Saharan Africa (all income levels) to that in Sub-Saharan Africa (developing only)?
Your answer should be very brief. 1. What is the ratio of the Aid flow (current US$) in 1961 in Sub-Saharan Africa (all income levels) to that in Sub-Saharan Africa (developing only)?
Your response must be concise. 1. What is the ratio of the Aid flow (current US$) of 1962 in Sub-Saharan Africa (all income levels) to that in Sub-Saharan Africa (developing only)?
Ensure brevity in your answer.  1. What is the difference between the highest and the second highest Aid flow (current US$) in 1960?
Offer a very short reply. 1.26e+07. What is the difference between the highest and the second highest Aid flow (current US$) of 1961?
Keep it short and to the point. 0. What is the difference between the highest and the second highest Aid flow (current US$) of 1962?
Provide a short and direct response. 4.20e+06. What is the difference between the highest and the second highest Aid flow (current US$) of 1963?
Make the answer very short. 0. What is the difference between the highest and the lowest Aid flow (current US$) in 1960?
Keep it short and to the point. 3.92e+08. What is the difference between the highest and the lowest Aid flow (current US$) of 1961?
Your answer should be very brief. 4.37e+08. What is the difference between the highest and the lowest Aid flow (current US$) in 1962?
Keep it short and to the point. 3.62e+08. What is the difference between the highest and the lowest Aid flow (current US$) of 1963?
Keep it short and to the point. 2.58e+08. 